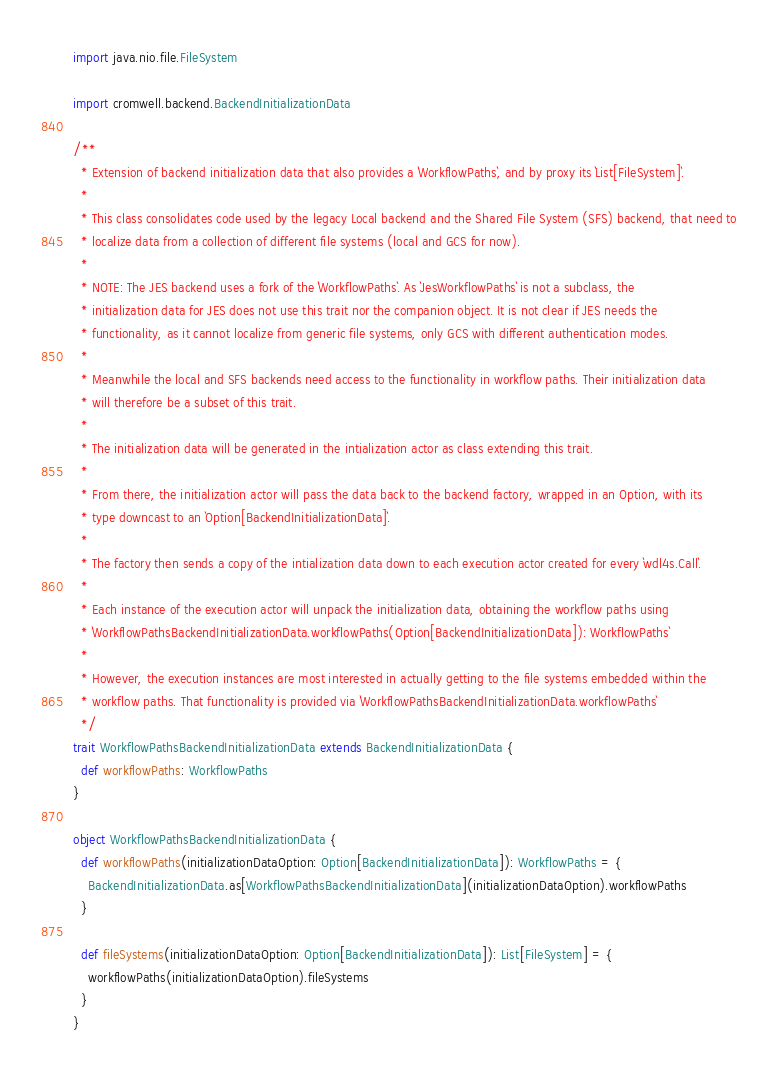<code> <loc_0><loc_0><loc_500><loc_500><_Scala_>
import java.nio.file.FileSystem

import cromwell.backend.BackendInitializationData

/**
  * Extension of backend initialization data that also provides a `WorkflowPaths`, and by proxy its `List[FileSystem]`.
  *
  * This class consolidates code used by the legacy Local backend and the Shared File System (SFS) backend, that need to
  * localize data from a collection of different file systems (local and GCS for now).
  *
  * NOTE: The JES backend uses a fork of the `WorkflowPaths`. As `JesWorkflowPaths` is not a subclass, the
  * initialization data for JES does not use this trait nor the companion object. It is not clear if JES needs the
  * functionality, as it cannot localize from generic file systems, only GCS with different authentication modes.
  *
  * Meanwhile the local and SFS backends need access to the functionality in workflow paths. Their initialization data
  * will therefore be a subset of this trait.
  *
  * The initialization data will be generated in the intialization actor as class extending this trait.
  *
  * From there, the initialization actor will pass the data back to the backend factory, wrapped in an Option, with its
  * type downcast to an `Option[BackendInitializationData]`.
  *
  * The factory then sends a copy of the intialization data down to each execution actor created for every `wdl4s.Call`.
  *
  * Each instance of the execution actor will unpack the initialization data, obtaining the workflow paths using
  * `WorkflowPathsBackendInitializationData.workflowPaths(Option[BackendInitializationData]): WorkflowPaths`
  *
  * However, the execution instances are most interested in actually getting to the file systems embedded within the
  * workflow paths. That functionality is provided via `WorkflowPathsBackendInitializationData.workflowPaths`
  */
trait WorkflowPathsBackendInitializationData extends BackendInitializationData {
  def workflowPaths: WorkflowPaths
}

object WorkflowPathsBackendInitializationData {
  def workflowPaths(initializationDataOption: Option[BackendInitializationData]): WorkflowPaths = {
    BackendInitializationData.as[WorkflowPathsBackendInitializationData](initializationDataOption).workflowPaths
  }

  def fileSystems(initializationDataOption: Option[BackendInitializationData]): List[FileSystem] = {
    workflowPaths(initializationDataOption).fileSystems
  }
}
</code> 